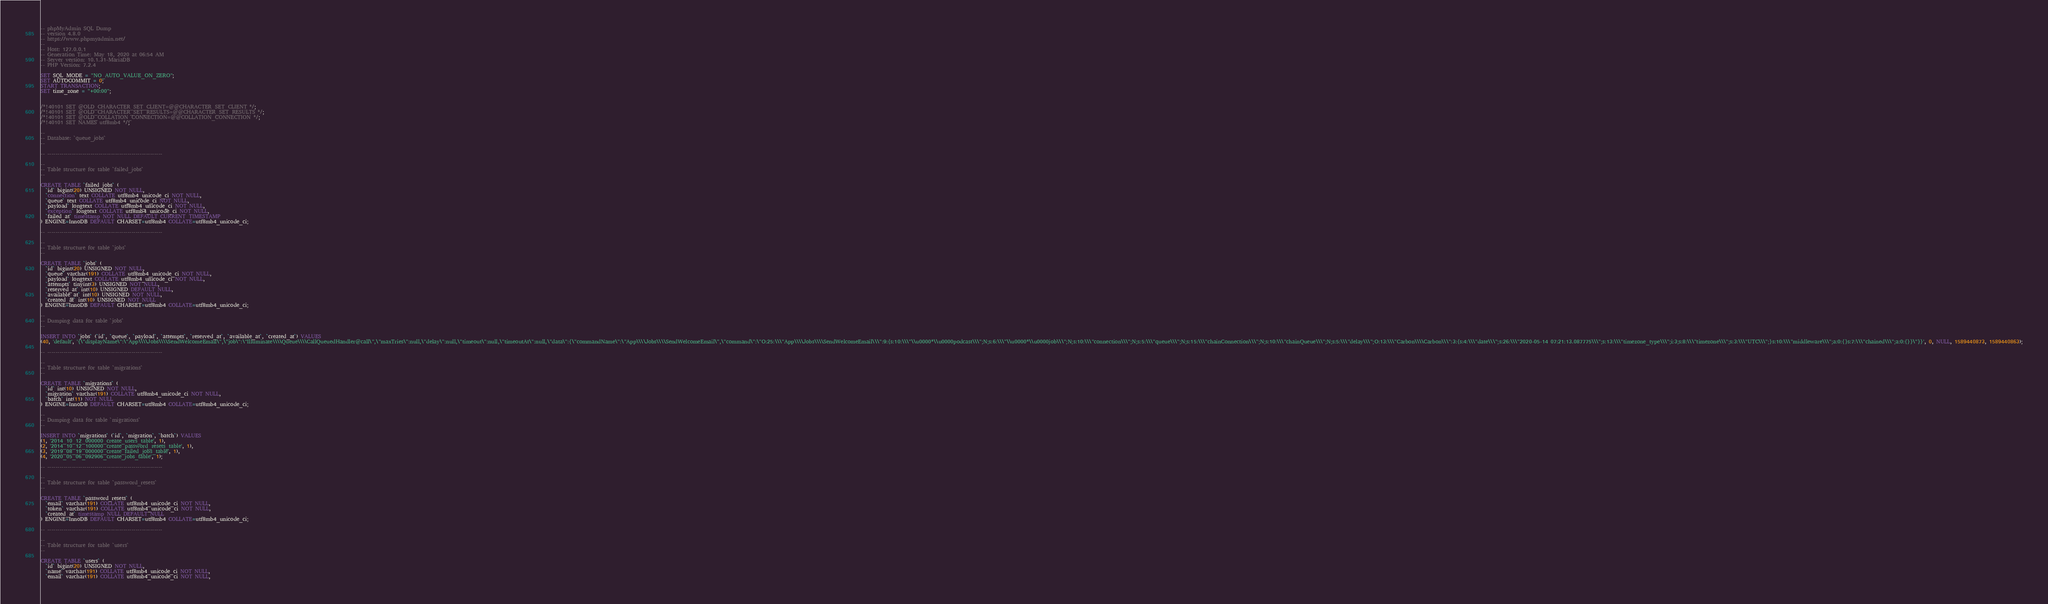<code> <loc_0><loc_0><loc_500><loc_500><_SQL_>-- phpMyAdmin SQL Dump
-- version 4.8.0
-- https://www.phpmyadmin.net/
--
-- Host: 127.0.0.1
-- Generation Time: May 18, 2020 at 06:54 AM
-- Server version: 10.1.31-MariaDB
-- PHP Version: 7.2.4

SET SQL_MODE = "NO_AUTO_VALUE_ON_ZERO";
SET AUTOCOMMIT = 0;
START TRANSACTION;
SET time_zone = "+00:00";


/*!40101 SET @OLD_CHARACTER_SET_CLIENT=@@CHARACTER_SET_CLIENT */;
/*!40101 SET @OLD_CHARACTER_SET_RESULTS=@@CHARACTER_SET_RESULTS */;
/*!40101 SET @OLD_COLLATION_CONNECTION=@@COLLATION_CONNECTION */;
/*!40101 SET NAMES utf8mb4 */;

--
-- Database: `queue_jobs`
--

-- --------------------------------------------------------

--
-- Table structure for table `failed_jobs`
--

CREATE TABLE `failed_jobs` (
  `id` bigint(20) UNSIGNED NOT NULL,
  `connection` text COLLATE utf8mb4_unicode_ci NOT NULL,
  `queue` text COLLATE utf8mb4_unicode_ci NOT NULL,
  `payload` longtext COLLATE utf8mb4_unicode_ci NOT NULL,
  `exception` longtext COLLATE utf8mb4_unicode_ci NOT NULL,
  `failed_at` timestamp NOT NULL DEFAULT CURRENT_TIMESTAMP
) ENGINE=InnoDB DEFAULT CHARSET=utf8mb4 COLLATE=utf8mb4_unicode_ci;

-- --------------------------------------------------------

--
-- Table structure for table `jobs`
--

CREATE TABLE `jobs` (
  `id` bigint(20) UNSIGNED NOT NULL,
  `queue` varchar(191) COLLATE utf8mb4_unicode_ci NOT NULL,
  `payload` longtext COLLATE utf8mb4_unicode_ci NOT NULL,
  `attempts` tinyint(3) UNSIGNED NOT NULL,
  `reserved_at` int(10) UNSIGNED DEFAULT NULL,
  `available_at` int(10) UNSIGNED NOT NULL,
  `created_at` int(10) UNSIGNED NOT NULL
) ENGINE=InnoDB DEFAULT CHARSET=utf8mb4 COLLATE=utf8mb4_unicode_ci;

--
-- Dumping data for table `jobs`
--

INSERT INTO `jobs` (`id`, `queue`, `payload`, `attempts`, `reserved_at`, `available_at`, `created_at`) VALUES
(40, 'default', '{\"displayName\":\"App\\\\Jobs\\\\SendWelcomeEmail\",\"job\":\"Illuminate\\\\Queue\\\\CallQueuedHandler@call\",\"maxTries\":null,\"delay\":null,\"timeout\":null,\"timeoutAt\":null,\"data\":{\"commandName\":\"App\\\\Jobs\\\\SendWelcomeEmail\",\"command\":\"O:25:\\\"App\\\\Jobs\\\\SendWelcomeEmail\\\":9:{s:10:\\\"\\u0000*\\u0000podcast\\\";N;s:6:\\\"\\u0000*\\u0000job\\\";N;s:10:\\\"connection\\\";N;s:5:\\\"queue\\\";N;s:15:\\\"chainConnection\\\";N;s:10:\\\"chainQueue\\\";N;s:5:\\\"delay\\\";O:13:\\\"Carbon\\\\Carbon\\\":3:{s:4:\\\"date\\\";s:26:\\\"2020-05-14 07:21:13.087775\\\";s:13:\\\"timezone_type\\\";i:3;s:8:\\\"timezone\\\";s:3:\\\"UTC\\\";}s:10:\\\"middleware\\\";a:0:{}s:7:\\\"chained\\\";a:0:{}}\"}}', 0, NULL, 1589440873, 1589440863);

-- --------------------------------------------------------

--
-- Table structure for table `migrations`
--

CREATE TABLE `migrations` (
  `id` int(10) UNSIGNED NOT NULL,
  `migration` varchar(191) COLLATE utf8mb4_unicode_ci NOT NULL,
  `batch` int(11) NOT NULL
) ENGINE=InnoDB DEFAULT CHARSET=utf8mb4 COLLATE=utf8mb4_unicode_ci;

--
-- Dumping data for table `migrations`
--

INSERT INTO `migrations` (`id`, `migration`, `batch`) VALUES
(1, '2014_10_12_000000_create_users_table', 1),
(2, '2014_10_12_100000_create_password_resets_table', 1),
(3, '2019_08_19_000000_create_failed_jobs_table', 1),
(4, '2020_05_06_092906_create_jobs_table', 1);

-- --------------------------------------------------------

--
-- Table structure for table `password_resets`
--

CREATE TABLE `password_resets` (
  `email` varchar(191) COLLATE utf8mb4_unicode_ci NOT NULL,
  `token` varchar(191) COLLATE utf8mb4_unicode_ci NOT NULL,
  `created_at` timestamp NULL DEFAULT NULL
) ENGINE=InnoDB DEFAULT CHARSET=utf8mb4 COLLATE=utf8mb4_unicode_ci;

-- --------------------------------------------------------

--
-- Table structure for table `users`
--

CREATE TABLE `users` (
  `id` bigint(20) UNSIGNED NOT NULL,
  `name` varchar(191) COLLATE utf8mb4_unicode_ci NOT NULL,
  `email` varchar(191) COLLATE utf8mb4_unicode_ci NOT NULL,</code> 